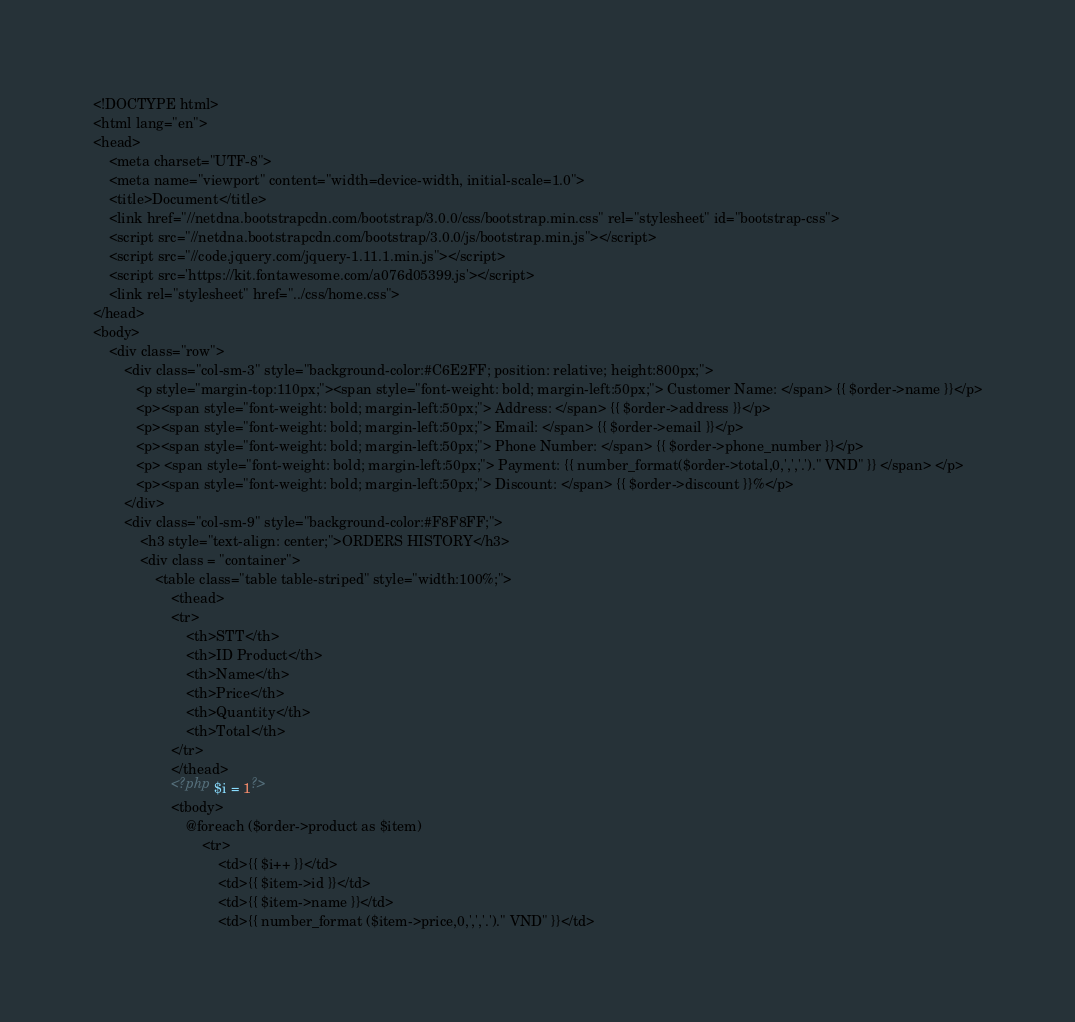Convert code to text. <code><loc_0><loc_0><loc_500><loc_500><_PHP_><!DOCTYPE html>
<html lang="en">
<head>
    <meta charset="UTF-8">
    <meta name="viewport" content="width=device-width, initial-scale=1.0">
    <title>Document</title>
    <link href="//netdna.bootstrapcdn.com/bootstrap/3.0.0/css/bootstrap.min.css" rel="stylesheet" id="bootstrap-css">
    <script src="//netdna.bootstrapcdn.com/bootstrap/3.0.0/js/bootstrap.min.js"></script>
    <script src="//code.jquery.com/jquery-1.11.1.min.js"></script>
    <script src='https://kit.fontawesome.com/a076d05399.js'></script>
    <link rel="stylesheet" href="../css/home.css">
</head>
<body>
    <div class="row">
        <div class="col-sm-3" style="background-color:#C6E2FF; position: relative; height:800px;">
           <p style="margin-top:110px;"><span style="font-weight: bold; margin-left:50px;"> Customer Name: </span> {{ $order->name }}</p>
           <p><span style="font-weight: bold; margin-left:50px;"> Address: </span> {{ $order->address }}</p>
           <p><span style="font-weight: bold; margin-left:50px;"> Email: </span> {{ $order->email }}</p>
           <p><span style="font-weight: bold; margin-left:50px;"> Phone Number: </span> {{ $order->phone_number }}</p>
           <p> <span style="font-weight: bold; margin-left:50px;"> Payment: {{ number_format($order->total,0,',','.')." VND" }} </span> </p>
           <p><span style="font-weight: bold; margin-left:50px;"> Discount: </span> {{ $order->discount }}%</p>
        </div>
        <div class="col-sm-9" style="background-color:#F8F8FF;">
            <h3 style="text-align: center;">ORDERS HISTORY</h3>
            <div class = "container">
                <table class="table table-striped" style="width:100%;">
                    <thead>
                    <tr>
                        <th>STT</th>
                        <th>ID Product</th>
                        <th>Name</th>
                        <th>Price</th>
                        <th>Quantity</th>
                        <th>Total</th>
                    </tr>
                    </thead>
                    <?php $i = 1?>
                    <tbody>
                        @foreach ($order->product as $item)
                            <tr>
                                <td>{{ $i++ }}</td>
                                <td>{{ $item->id }}</td>
                                <td>{{ $item->name }}</td>
                                <td>{{ number_format ($item->price,0,',','.')." VND" }}</td></code> 